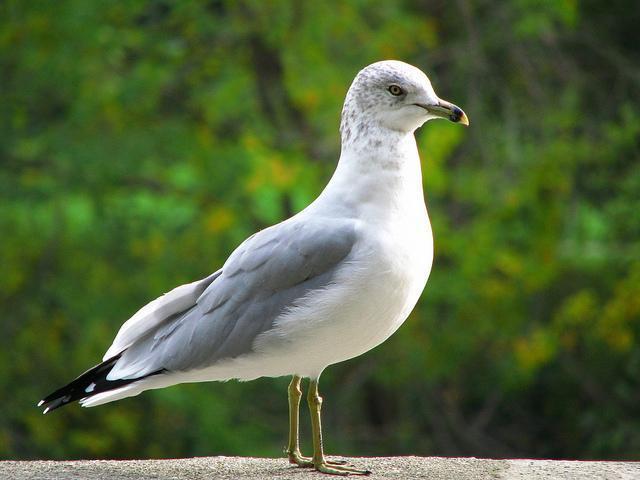How many cars are parked on the street?
Give a very brief answer. 0. 